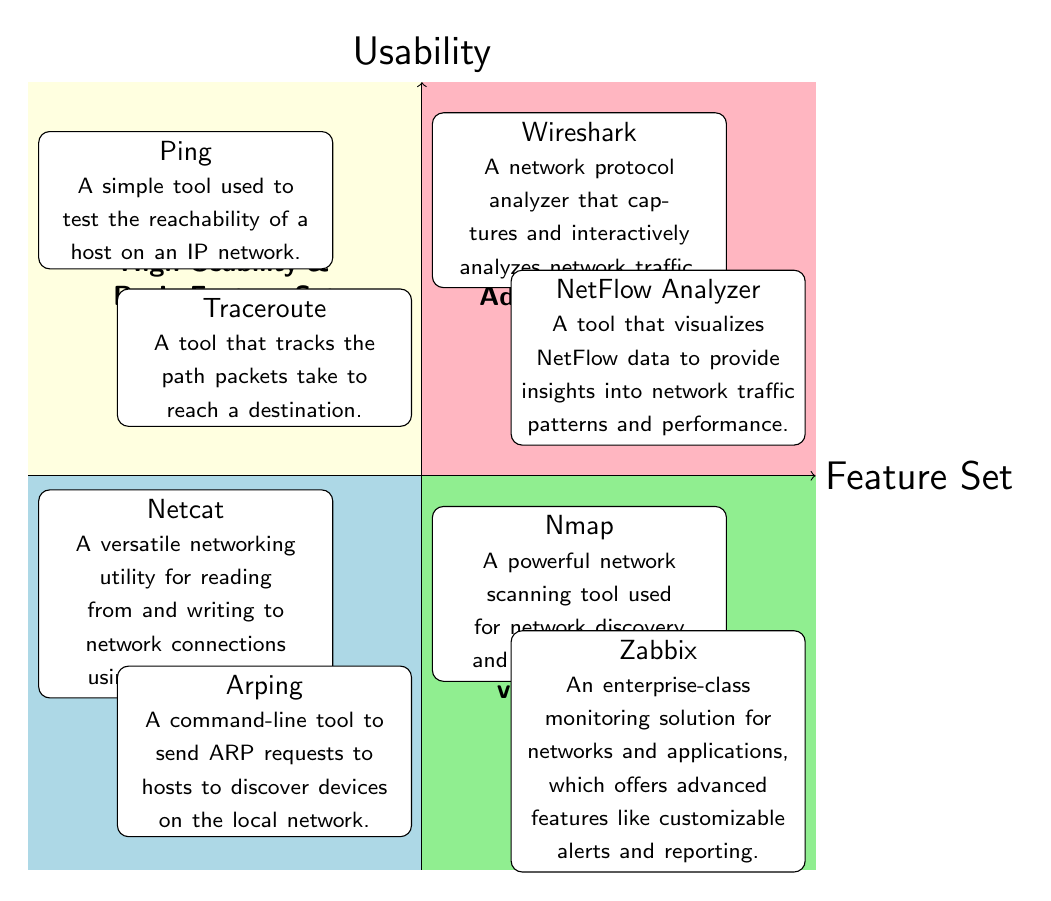What tools are in the "High Usability & Basic Feature Set" quadrant? The diagram indicates that the "High Usability & Basic Feature Set" quadrant contains two tools: Ping and Traceroute. Each tool is listed in that section, which is located in the upper left portion of the diagram.
Answer: Ping, Traceroute How many tools are categorized under "Low Usability & Advanced Feature Set"? In the diagram, the "Low Usability & Advanced Feature Set" quadrant is shown to feature two tools: Nmap and Zabbix. This count is based on the information displayed within the lower right section of the quadrant chart.
Answer: 2 What is the feature set of Wireshark? Wireshark is categorized in the "High Usability & Advanced Feature Set" quadrant according to the diagram's placement, which indicates it possesses advanced feature capabilities with high usability.
Answer: Advanced Feature Set Which tool is found in both "High Usability" quadrants? Upon examining both the high usability quadrants separately, only one tool, Wireshark, is included in the "High Usability & Advanced Feature Set," thereby confirming it is in the high usability category.
Answer: Wireshark Which quadrant contains Netcat and Arping? The "Low Usability & Basic Feature Set" quadrant contains both Netcat and Arping, positioned at the lower left area of the diagram. This placement shows they are associated with basic features but have low usability.
Answer: Low Usability & Basic Feature Set What is the main distinction between quadrants regarding usability? The main distinction depicted in the diagram is between the high usability quadrants (upper half) and the low usability quadrants (lower half). This differentiation clearly categorizes tools based on their usability levels.
Answer: Usability levels Which tool provides monitoring capabilities with advanced features? Zabbix is specifically noted in the "Low Usability & Advanced Feature Set" quadrant as an enterprise-class monitoring solution for networks and applications, emphasizing its advanced feature set.
Answer: Zabbix How many total quadrants are represented in this chart? The chart features a total of four quadrants, distinctly divided by usability and feature set, resulting in a clear and organized categorization of networking tools.
Answer: 4 What quadrant includes the most user-friendly tools? The "High Usability & Basic Feature Set" quadrant is where the most user-friendly tools, Ping and Traceroute, are placed, indicating they are straightforward in terms of usability while offering basic features.
Answer: High Usability & Basic Feature Set 